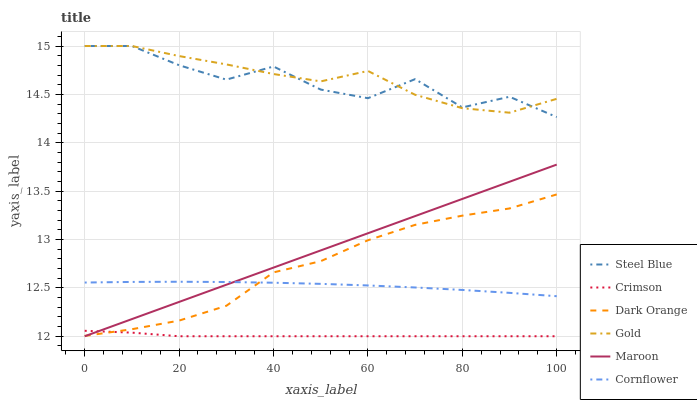Does Crimson have the minimum area under the curve?
Answer yes or no. Yes. Does Gold have the maximum area under the curve?
Answer yes or no. Yes. Does Cornflower have the minimum area under the curve?
Answer yes or no. No. Does Cornflower have the maximum area under the curve?
Answer yes or no. No. Is Maroon the smoothest?
Answer yes or no. Yes. Is Steel Blue the roughest?
Answer yes or no. Yes. Is Gold the smoothest?
Answer yes or no. No. Is Gold the roughest?
Answer yes or no. No. Does Cornflower have the lowest value?
Answer yes or no. No. Does Steel Blue have the highest value?
Answer yes or no. Yes. Does Cornflower have the highest value?
Answer yes or no. No. Is Cornflower less than Steel Blue?
Answer yes or no. Yes. Is Gold greater than Dark Orange?
Answer yes or no. Yes. Does Steel Blue intersect Gold?
Answer yes or no. Yes. Is Steel Blue less than Gold?
Answer yes or no. No. Is Steel Blue greater than Gold?
Answer yes or no. No. Does Cornflower intersect Steel Blue?
Answer yes or no. No. 